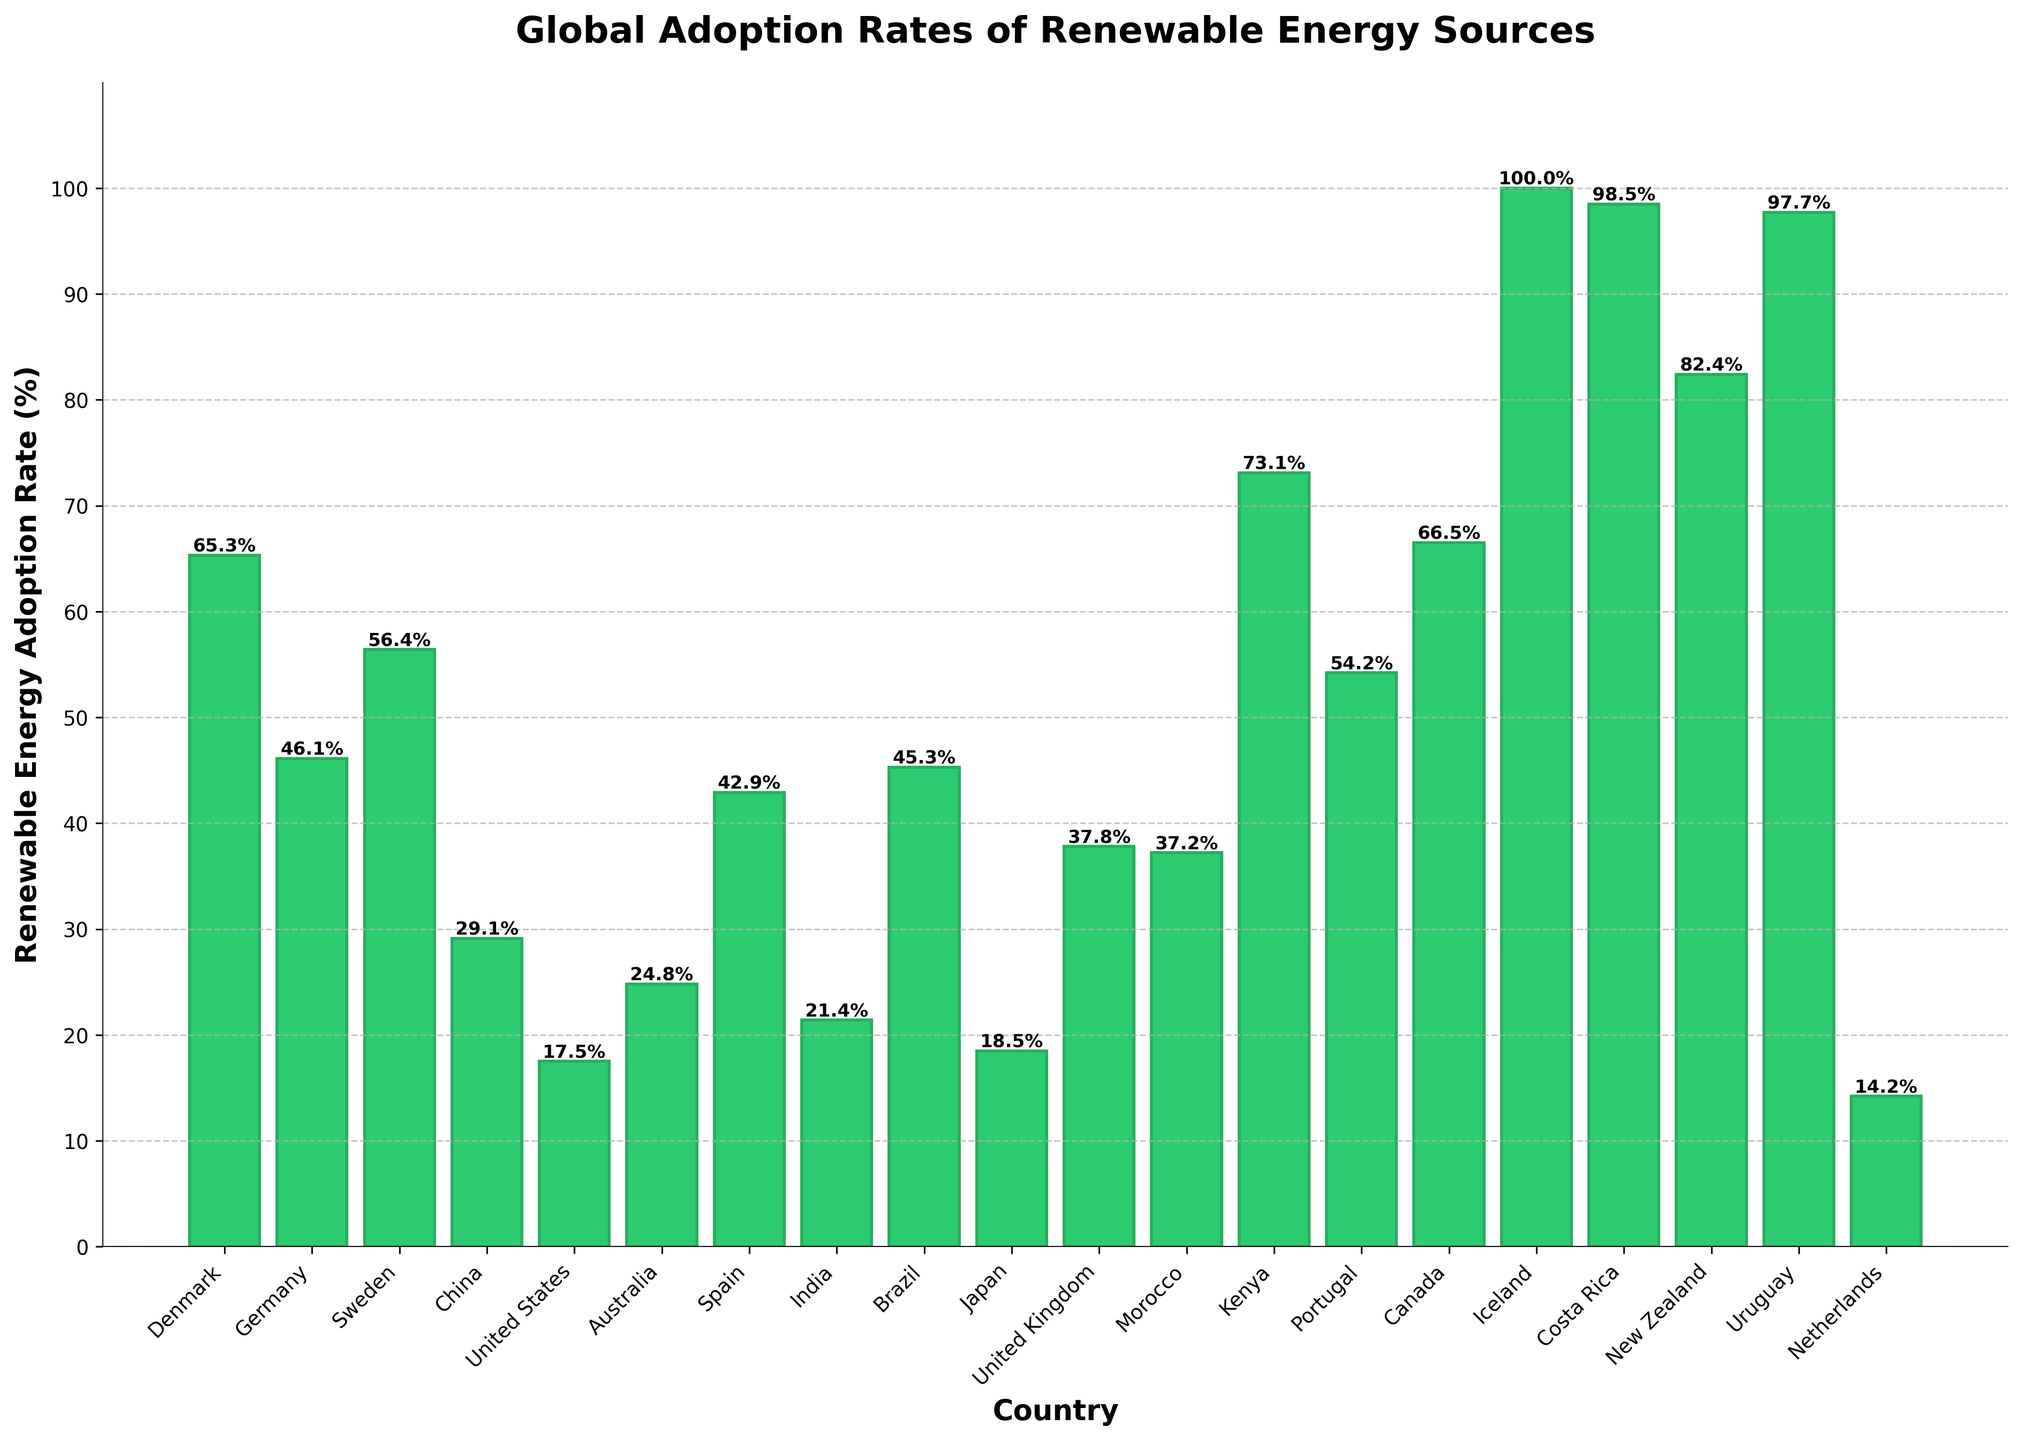Which country has the highest renewable energy adoption rate? The country with the highest renewable energy adoption rate can be identified as the one with the tallest bar. In the figure, Iceland has the tallest bar, indicating an adoption rate of 100%.
Answer: Iceland Which country has the lowest renewable energy adoption rate? The country with the lowest renewable energy adoption rate is the one with the shortest bar. In the figure, the Netherlands has the shortest bar, indicating an adoption rate of 14.2%.
Answer: Netherlands What's the average renewable energy adoption rate of the top five countries? To find the average adoption rate of the top five countries, identify the countries with the highest rates: Iceland (100.0%), Costa Rica (98.5%), Uruguay (97.7%), New Zealand (82.4%), and Kenya (73.1%). Sum these rates and divide by 5. (100.0 + 98.5 + 97.7 + 82.4 + 73.1) / 5 = 90.34%
Answer: 90.34% Compare the renewable energy adoption rates of Denmark and Germany. Which country has a higher rate and by how much? Denmark has a rate of 65.3% and Germany has 46.1%. Subtract Germany’s rate from Denmark’s rate to determine the difference: 65.3 - 46.1 = 19.2%. Thus, Denmark’s rate is 19.2% higher than Germany’s.
Answer: Denmark; 19.2% Identify the countries that have a renewable energy adoption rate greater than 50%. How many such countries are there? Look for countries with bars extending beyond the 50% mark. The countries are Denmark (65.3%), Germany (56.4%), Kenya (73.1%), Portugal (54.2%), and Canada (66.5%). There are 5 such countries.
Answer: 5 What is the total renewable energy adoption rate of the bottom three countries? Identify and sum the adoption rates of the countries with the smallest bars: Netherlands (14.2%), United States (17.5%), and Japan (18.5%). (14.2 + 17.5 + 18.5) = 50.2%
Answer: 50.2% Which country has a renewable energy adoption rate closest to the average adoption rate of all countries illustrated? Calculate the average rate by summing all adoption rates and dividing by the number of countries (20). The total sum is (65.3 + 46.1 + 56.4 + 29.1 + 17.5 + 24.8 + 42.9 + 21.4 + 45.3 + 18.5 + 37.8 + 37.2 + 73.1 + 54.2 + 66.5 + 100.0 + 98.5 + 82.4 + 97.7 + 14.2) = 959.9. The average rate is 959.9 / 20 = 48.0%. Spain, with an adoption rate of 42.9%, is the closest to this average.
Answer: Spain Which countries have a renewable energy adoption rate between 30% and 40%? Look for bars that fall within the 30%-40% range on the vertical axis. The countries meeting this criterion are the United Kingdom (37.8%) and Morocco (37.2%).
Answer: United Kingdom, Morocco What is the difference in renewable energy adoption rates between Australia and Brazil? Australia has a rate of 24.8% and Brazil has 45.3%. Subtract Australia’s rate from Brazil’s rate to get the difference: 45.3 - 24.8 = 20.5%.
Answer: 20.5 